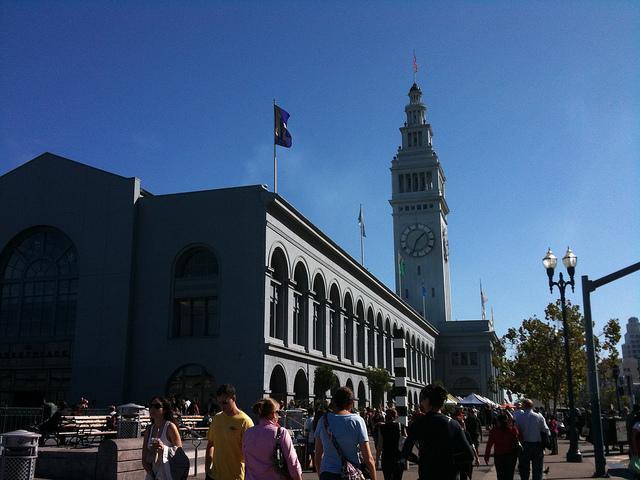How many women are wearing pink shirts?
Give a very brief answer. 1. How many street lights are visible on the light pole on the right?
Give a very brief answer. 2. How many people can you see?
Give a very brief answer. 6. 